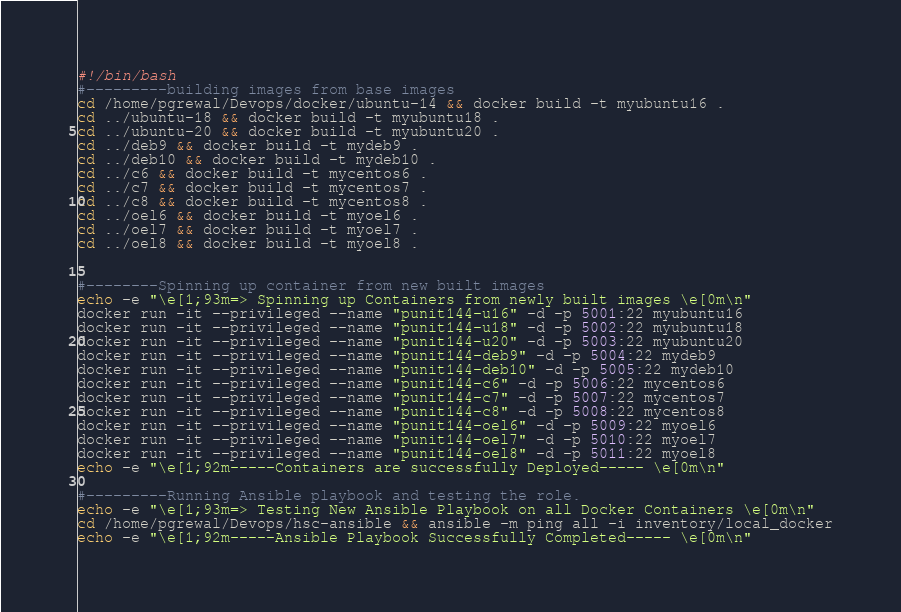Convert code to text. <code><loc_0><loc_0><loc_500><loc_500><_Bash_>#!/bin/bash
#---------building images from base images
cd /home/pgrewal/Devops/docker/ubuntu-14 && docker build -t myubuntu16 .
cd ../ubuntu-18 && docker build -t myubuntu18 .
cd ../ubuntu-20 && docker build -t myubuntu20 .
cd ../deb9 && docker build -t mydeb9 .
cd ../deb10 && docker build -t mydeb10 .
cd ../c6 && docker build -t mycentos6 .
cd ../c7 && docker build -t mycentos7 .
cd ../c8 && docker build -t mycentos8 .
cd ../oel6 && docker build -t myoel6 .
cd ../oel7 && docker build -t myoel7 .
cd ../oel8 && docker build -t myoel8 .


#--------Spinning up container from new built images
echo -e "\e[1;93m=> Spinning up Containers from newly built images \e[0m\n"
docker run -it --privileged --name "punit144-u16" -d -p 5001:22 myubuntu16
docker run -it --privileged --name "punit144-u18" -d -p 5002:22 myubuntu18
docker run -it --privileged --name "punit144-u20" -d -p 5003:22 myubuntu20
docker run -it --privileged --name "punit144-deb9" -d -p 5004:22 mydeb9
docker run -it --privileged --name "punit144-deb10" -d -p 5005:22 mydeb10
docker run -it --privileged --name "punit144-c6" -d -p 5006:22 mycentos6
docker run -it --privileged --name "punit144-c7" -d -p 5007:22 mycentos7
docker run -it --privileged --name "punit144-c8" -d -p 5008:22 mycentos8
docker run -it --privileged --name "punit144-oel6" -d -p 5009:22 myoel6
docker run -it --privileged --name "punit144-oel7" -d -p 5010:22 myoel7
docker run -it --privileged --name "punit144-oel8" -d -p 5011:22 myoel8
echo -e "\e[1;92m-----Containers are successfully Deployed----- \e[0m\n"

#---------Running Ansible playbook and testing the role.
echo -e "\e[1;93m=> Testing New Ansible Playbook on all Docker Containers \e[0m\n"
cd /home/pgrewal/Devops/hsc-ansible && ansible -m ping all -i inventory/local_docker
echo -e "\e[1;92m-----Ansible Playbook Successfully Completed----- \e[0m\n"
</code> 